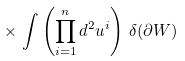Convert formula to latex. <formula><loc_0><loc_0><loc_500><loc_500>\times \, \int \left ( \prod _ { i = 1 } ^ { n } d ^ { 2 } u ^ { i } \right ) \, \delta ( \partial W )</formula> 